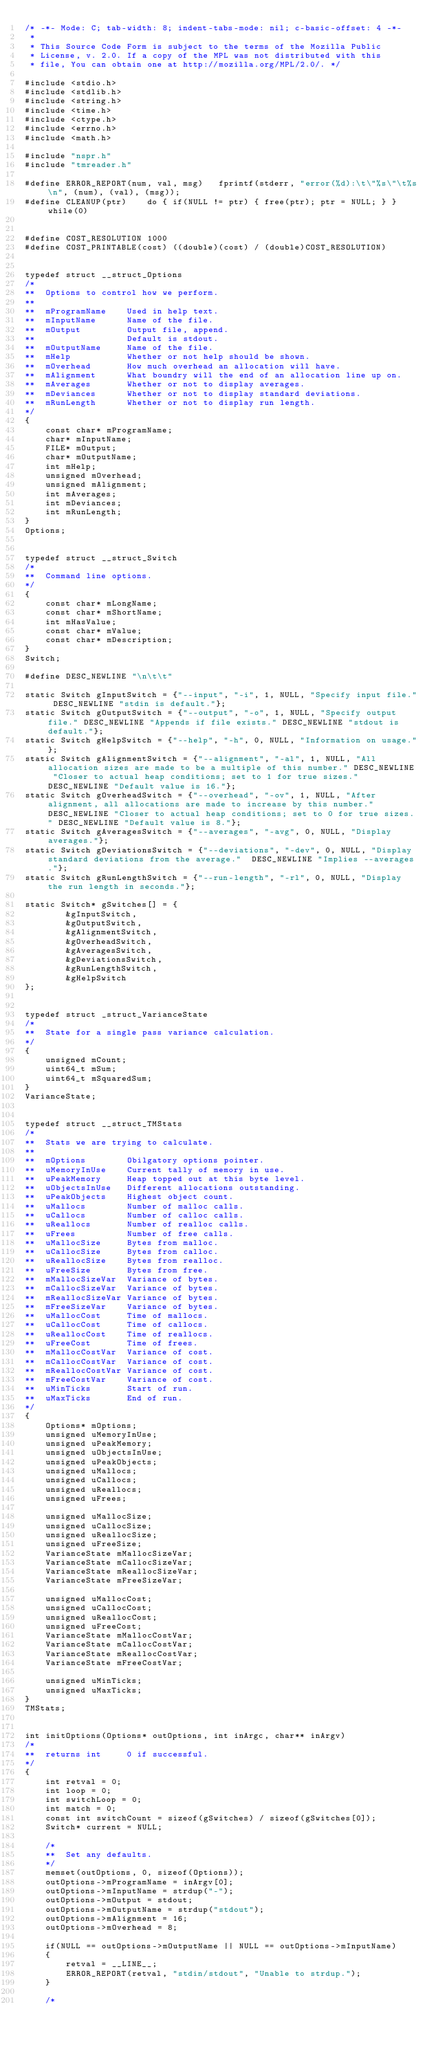Convert code to text. <code><loc_0><loc_0><loc_500><loc_500><_C_>/* -*- Mode: C; tab-width: 8; indent-tabs-mode: nil; c-basic-offset: 4 -*-
 *
 * This Source Code Form is subject to the terms of the Mozilla Public
 * License, v. 2.0. If a copy of the MPL was not distributed with this
 * file, You can obtain one at http://mozilla.org/MPL/2.0/. */

#include <stdio.h>
#include <stdlib.h>
#include <string.h>
#include <time.h>
#include <ctype.h>
#include <errno.h>
#include <math.h>

#include "nspr.h"
#include "tmreader.h"

#define ERROR_REPORT(num, val, msg)   fprintf(stderr, "error(%d):\t\"%s\"\t%s\n", (num), (val), (msg));
#define CLEANUP(ptr)    do { if(NULL != ptr) { free(ptr); ptr = NULL; } } while(0)


#define COST_RESOLUTION 1000
#define COST_PRINTABLE(cost) ((double)(cost) / (double)COST_RESOLUTION)


typedef struct __struct_Options
/*
**  Options to control how we perform.
**
**  mProgramName    Used in help text.
**  mInputName      Name of the file.
**  mOutput         Output file, append.
**                  Default is stdout.
**  mOutputName     Name of the file.
**  mHelp           Whether or not help should be shown.
**  mOverhead       How much overhead an allocation will have.
**  mAlignment      What boundry will the end of an allocation line up on.
**  mAverages       Whether or not to display averages.
**  mDeviances      Whether or not to display standard deviations.
**  mRunLength      Whether or not to display run length.
*/
{
    const char* mProgramName;
    char* mInputName;
    FILE* mOutput;
    char* mOutputName;
    int mHelp;
    unsigned mOverhead;
    unsigned mAlignment;
    int mAverages;
    int mDeviances;
    int mRunLength;
}
Options;


typedef struct __struct_Switch
/*
**  Command line options.
*/
{
    const char* mLongName;
    const char* mShortName;
    int mHasValue;
    const char* mValue;
    const char* mDescription;
}
Switch;

#define DESC_NEWLINE "\n\t\t"

static Switch gInputSwitch = {"--input", "-i", 1, NULL, "Specify input file." DESC_NEWLINE "stdin is default."};
static Switch gOutputSwitch = {"--output", "-o", 1, NULL, "Specify output file." DESC_NEWLINE "Appends if file exists." DESC_NEWLINE "stdout is default."};
static Switch gHelpSwitch = {"--help", "-h", 0, NULL, "Information on usage."};
static Switch gAlignmentSwitch = {"--alignment", "-al", 1, NULL, "All allocation sizes are made to be a multiple of this number." DESC_NEWLINE "Closer to actual heap conditions; set to 1 for true sizes." DESC_NEWLINE "Default value is 16."};
static Switch gOverheadSwitch = {"--overhead", "-ov", 1, NULL, "After alignment, all allocations are made to increase by this number." DESC_NEWLINE "Closer to actual heap conditions; set to 0 for true sizes." DESC_NEWLINE "Default value is 8."};
static Switch gAveragesSwitch = {"--averages", "-avg", 0, NULL, "Display averages."};
static Switch gDeviationsSwitch = {"--deviations", "-dev", 0, NULL, "Display standard deviations from the average."  DESC_NEWLINE "Implies --averages."};
static Switch gRunLengthSwitch = {"--run-length", "-rl", 0, NULL, "Display the run length in seconds."};

static Switch* gSwitches[] = {
        &gInputSwitch,
        &gOutputSwitch,
        &gAlignmentSwitch,
        &gOverheadSwitch,
        &gAveragesSwitch,
        &gDeviationsSwitch,
        &gRunLengthSwitch,
        &gHelpSwitch
};


typedef struct _struct_VarianceState
/*
**  State for a single pass variance calculation.
*/
{
    unsigned mCount;
    uint64_t mSum;
    uint64_t mSquaredSum;
}
VarianceState;


typedef struct __struct_TMStats
/*
**  Stats we are trying to calculate.
**
**  mOptions        Obilgatory options pointer.
**  uMemoryInUse    Current tally of memory in use.
**  uPeakMemory     Heap topped out at this byte level.
**  uObjectsInUse   Different allocations outstanding.
**  uPeakObjects    Highest object count.
**  uMallocs        Number of malloc calls.
**  uCallocs        Number of calloc calls.
**  uReallocs       Number of realloc calls.
**  uFrees          Number of free calls.
**  uMallocSize     Bytes from malloc.
**  uCallocSize     Bytes from calloc.
**  uReallocSize    Bytes from realloc.
**  uFreeSize       Bytes from free.
**  mMallocSizeVar  Variance of bytes.
**  mCallocSizeVar  Variance of bytes.
**  mReallocSizeVar Variance of bytes.
**  mFreeSizeVar    Variance of bytes.
**  uMallocCost     Time of mallocs.
**  uCallocCost     Time of callocs.
**  uReallocCost    Time of reallocs.
**  uFreeCost       Time of frees.
**  mMallocCostVar  Variance of cost.
**  mCallocCostVar  Variance of cost.
**  mReallocCostVar Variance of cost.
**  mFreeCostVar    Variance of cost.
**  uMinTicks       Start of run.
**  uMaxTicks       End of run.
*/
{
    Options* mOptions;
    unsigned uMemoryInUse;
    unsigned uPeakMemory;
    unsigned uObjectsInUse;
    unsigned uPeakObjects;
    unsigned uMallocs;
    unsigned uCallocs;
    unsigned uReallocs;
    unsigned uFrees;

    unsigned uMallocSize;
    unsigned uCallocSize;
    unsigned uReallocSize;
    unsigned uFreeSize;
    VarianceState mMallocSizeVar;
    VarianceState mCallocSizeVar;
    VarianceState mReallocSizeVar;
    VarianceState mFreeSizeVar;

    unsigned uMallocCost;
    unsigned uCallocCost;
    unsigned uReallocCost;
    unsigned uFreeCost;
    VarianceState mMallocCostVar;
    VarianceState mCallocCostVar;
    VarianceState mReallocCostVar;
    VarianceState mFreeCostVar;

    unsigned uMinTicks;
    unsigned uMaxTicks;
}
TMStats;


int initOptions(Options* outOptions, int inArgc, char** inArgv)
/*
**  returns int     0 if successful.
*/
{
    int retval = 0;
    int loop = 0;
    int switchLoop = 0;
    int match = 0;
    const int switchCount = sizeof(gSwitches) / sizeof(gSwitches[0]);
    Switch* current = NULL;

    /*
    **  Set any defaults.
    */
    memset(outOptions, 0, sizeof(Options));
    outOptions->mProgramName = inArgv[0];
    outOptions->mInputName = strdup("-");
    outOptions->mOutput = stdout;
    outOptions->mOutputName = strdup("stdout");
    outOptions->mAlignment = 16;
    outOptions->mOverhead = 8;

    if(NULL == outOptions->mOutputName || NULL == outOptions->mInputName)
    {
        retval = __LINE__;
        ERROR_REPORT(retval, "stdin/stdout", "Unable to strdup.");
    }

    /*</code> 